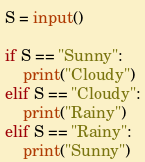<code> <loc_0><loc_0><loc_500><loc_500><_Python_>S = input()

if S == "Sunny":
    print("Cloudy")
elif S == "Cloudy":
    print("Rainy")
elif S == "Rainy":
    print("Sunny")

</code> 